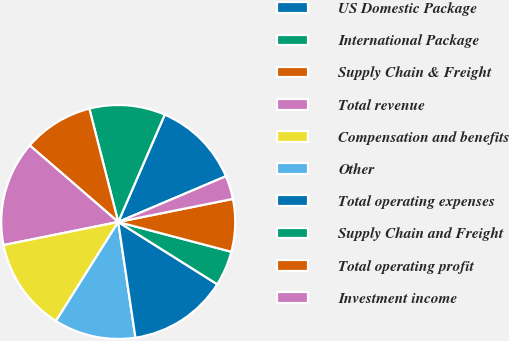<chart> <loc_0><loc_0><loc_500><loc_500><pie_chart><fcel>US Domestic Package<fcel>International Package<fcel>Supply Chain & Freight<fcel>Total revenue<fcel>Compensation and benefits<fcel>Other<fcel>Total operating expenses<fcel>Supply Chain and Freight<fcel>Total operating profit<fcel>Investment income<nl><fcel>12.1%<fcel>10.48%<fcel>9.68%<fcel>14.52%<fcel>12.9%<fcel>11.29%<fcel>13.71%<fcel>4.84%<fcel>7.26%<fcel>3.23%<nl></chart> 